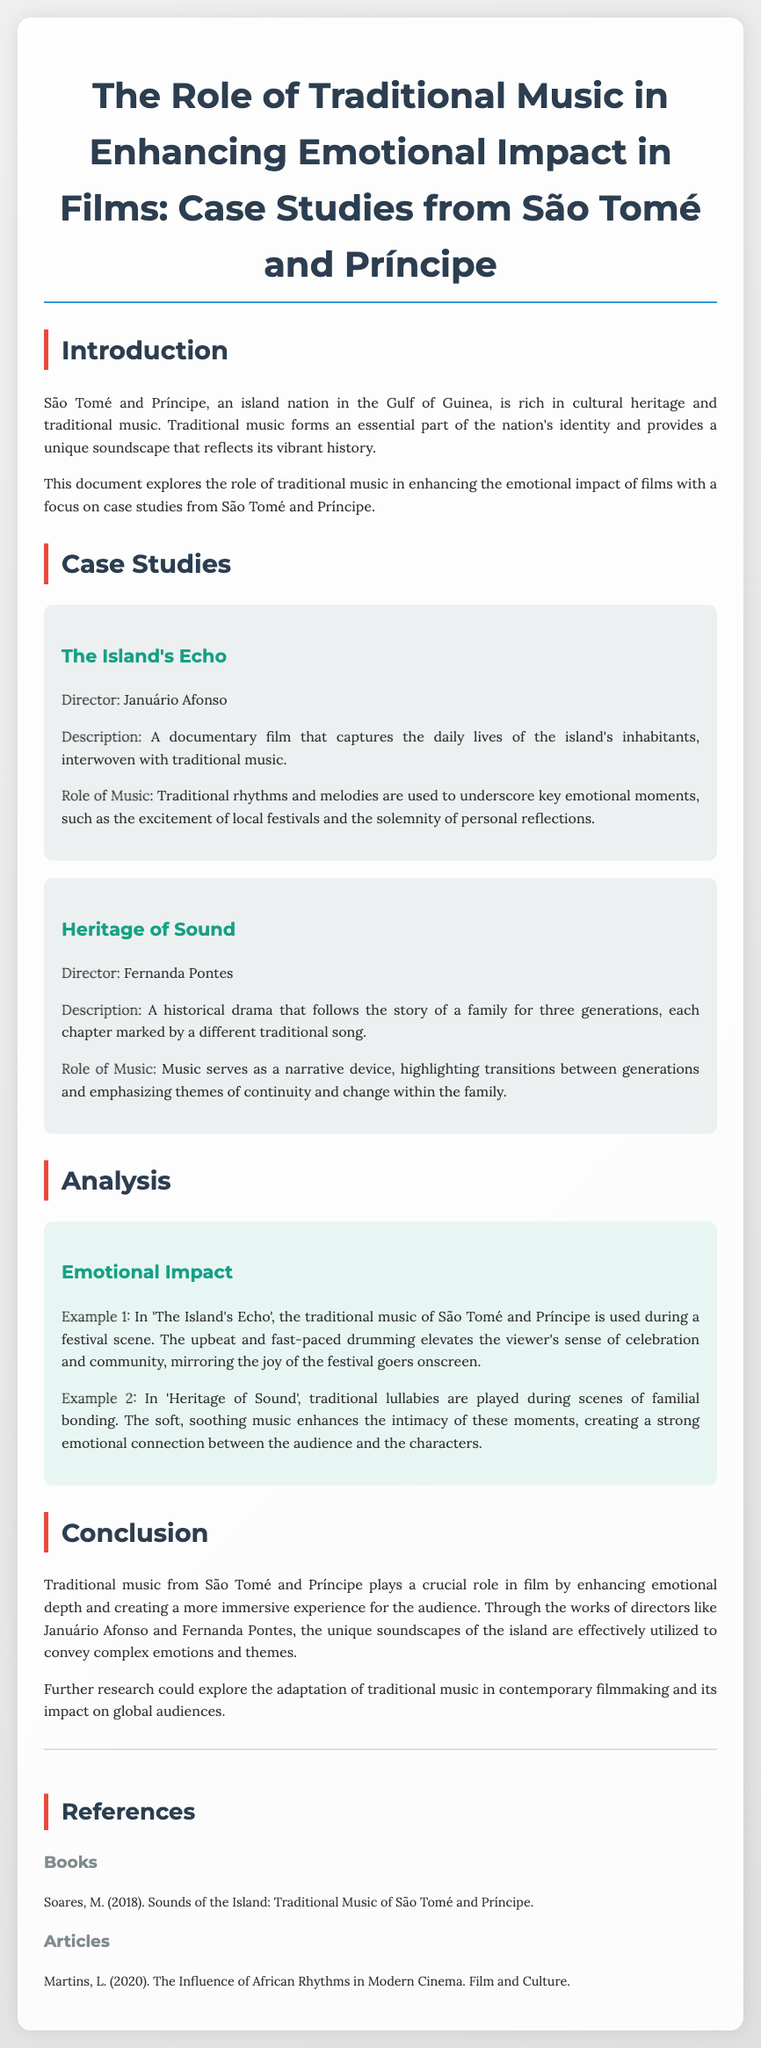What is the title of the document? The title is mentioned at the beginning of the document and summarizes the main focus of the content.
Answer: The Role of Traditional Music in Enhancing Emotional Impact in Films: Case Studies from São Tomé and Príncipe Who directed "The Island's Echo"? The director's name is provided under the case study section for the film.
Answer: Januário Afonso What type of film is "Heritage of Sound"? The document specifies the genre of the film within the description of the case study.
Answer: Historical drama What is the primary role of traditional music in "The Island's Echo"? The role of music is described in the case study for each film, highlighting its function in relation to emotions.
Answer: Underscore key emotional moments In which scene is traditional music used to enhance the sense of celebration? The specific example and context of music usage are provided in the analysis section.
Answer: Festival scene Which publication discusses the influence of African rhythms in modern cinema? The reference list includes articles, specifically naming the relevant one about African rhythms.
Answer: Martins, L. (2020). The Influence of African Rhythms in Modern Cinema. Film and Culture What enhances the intimacy of familial bonding scenes in "Heritage of Sound"? The analysis describes specific elements of music that contribute to emotional connections in the film.
Answer: Traditional lullabies 